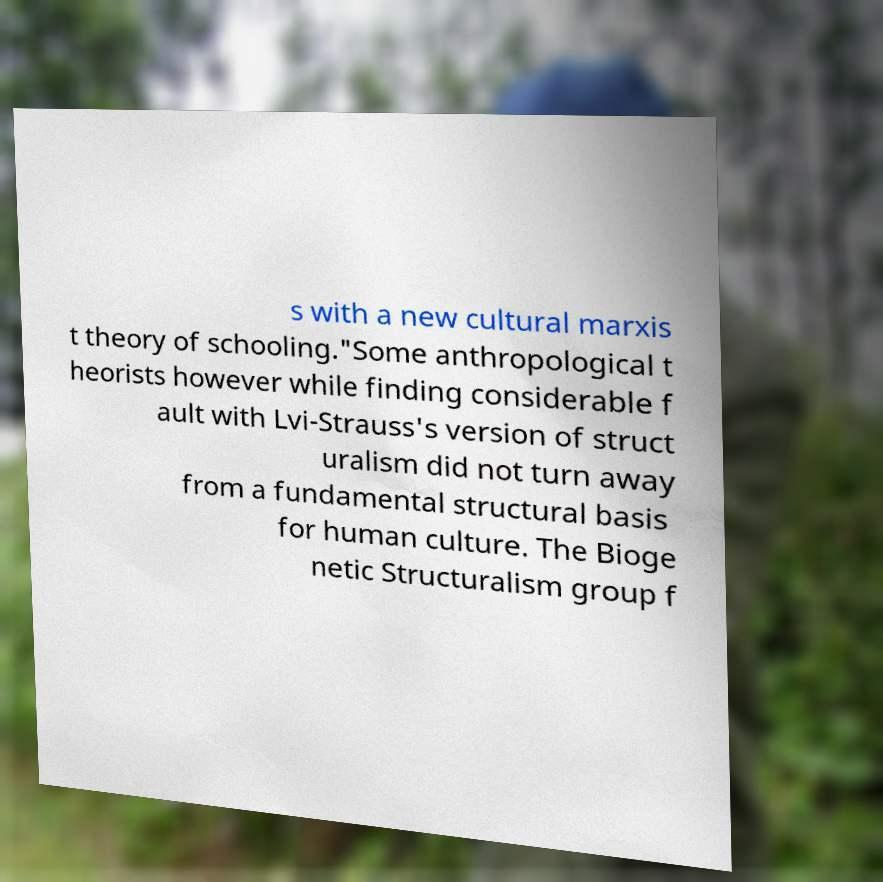Could you assist in decoding the text presented in this image and type it out clearly? s with a new cultural marxis t theory of schooling."Some anthropological t heorists however while finding considerable f ault with Lvi-Strauss's version of struct uralism did not turn away from a fundamental structural basis for human culture. The Bioge netic Structuralism group f 